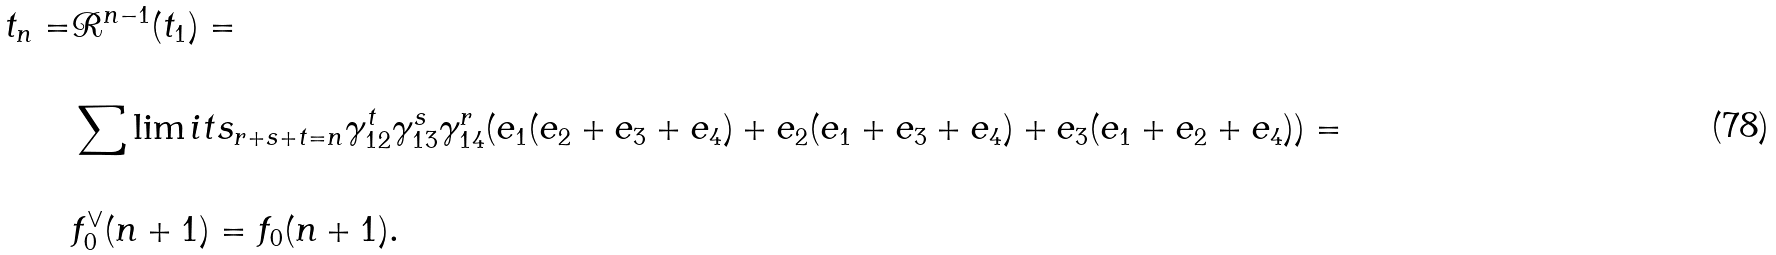Convert formula to latex. <formula><loc_0><loc_0><loc_500><loc_500>& \\ t _ { n } = & \mathcal { R } ^ { n - 1 } ( t _ { 1 } ) = \\ & \\ & \sum \lim i t s _ { r + s + t = n } \gamma ^ { t } _ { 1 2 } \gamma ^ { s } _ { 1 3 } \gamma ^ { r } _ { 1 4 } ( e _ { 1 } ( e _ { 2 } + e _ { 3 } + e _ { 4 } ) + e _ { 2 } ( e _ { 1 } + e _ { 3 } + e _ { 4 } ) + e _ { 3 } ( e _ { 1 } + e _ { 2 } + e _ { 4 } ) ) = \\ & \\ & f ^ { \vee } _ { 0 } ( n + 1 ) = f _ { 0 } ( n + 1 ) . \\ & \\</formula> 